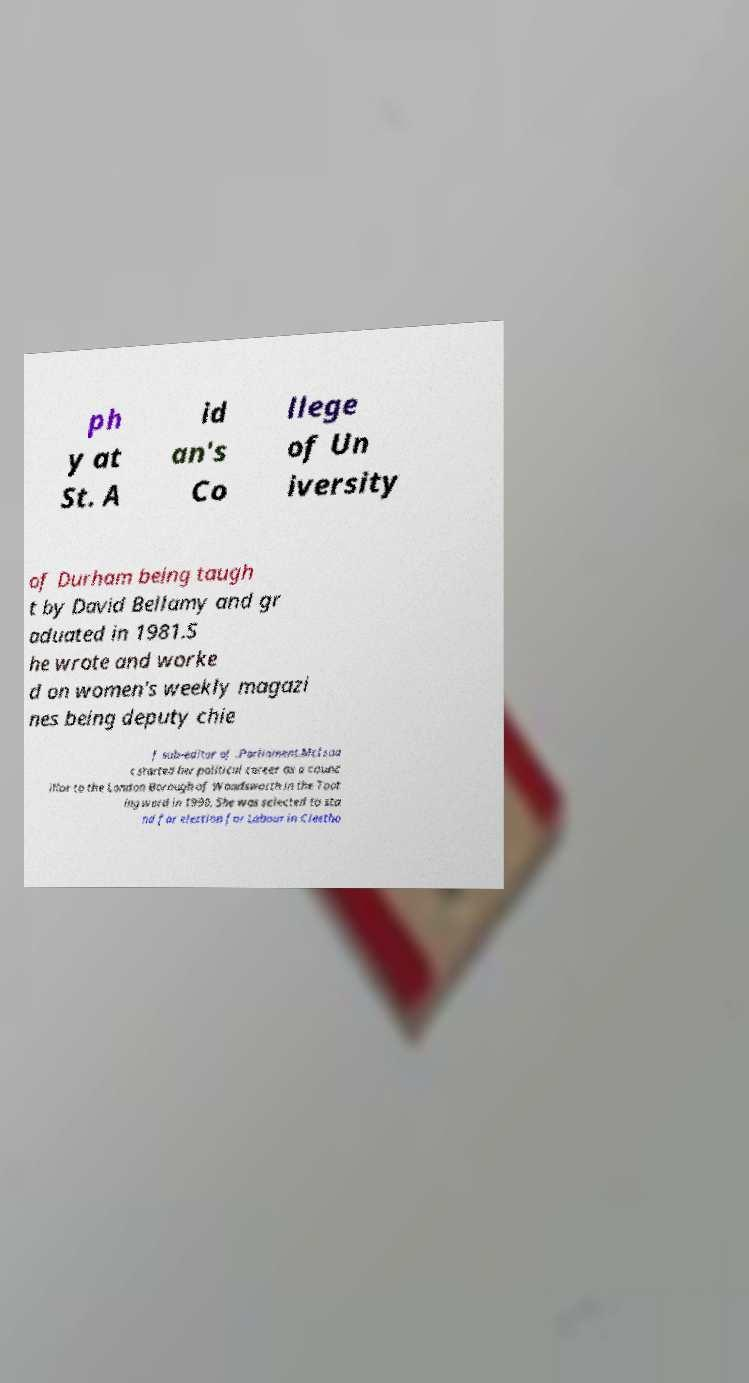Can you read and provide the text displayed in the image?This photo seems to have some interesting text. Can you extract and type it out for me? ph y at St. A id an's Co llege of Un iversity of Durham being taugh t by David Bellamy and gr aduated in 1981.S he wrote and worke d on women's weekly magazi nes being deputy chie f sub-editor of .Parliament.McIsaa c started her political career as a counc illor to the London Borough of Wandsworth in the Toot ing ward in 1990. She was selected to sta nd for election for Labour in Cleetho 